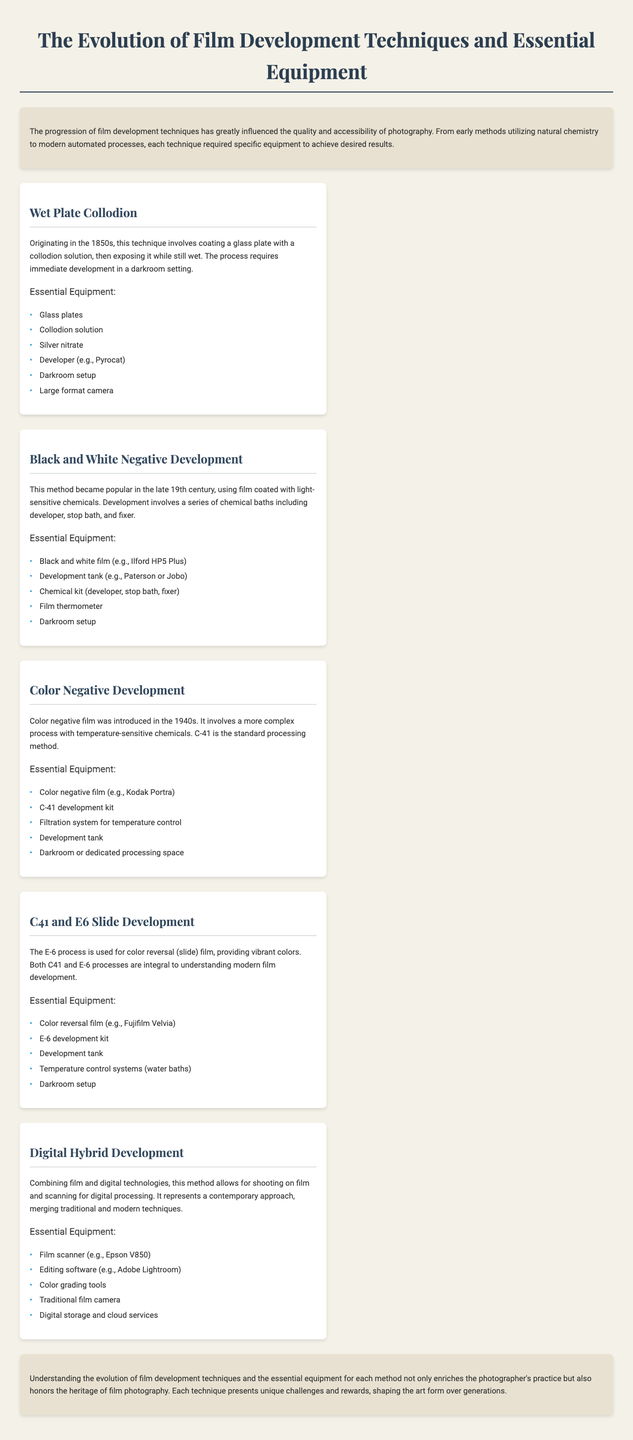What is the first film development technique mentioned? The first technique in the document is Wet Plate Collodion, which was introduced in the 1850s.
Answer: Wet Plate Collodion What year did color negative film become popular? The document states that color negative film was introduced in the 1940s.
Answer: 1940s Which equipment is essential for Black and White Negative Development? The essential equipment list for Black and White Negative Development includes specific items such as the development tank, film thermometer, and others.
Answer: Development tank What is the main purpose of the E-6 process? The E-6 process is primarily used for color reversal (slide) film, noted for producing vibrant colors.
Answer: Color reversal How many key techniques are highlighted in the document? The document outlines five key film development techniques that are detailed.
Answer: Five Which film scanner is recommended in the Digital Hybrid Development section? The document specifies the Epson V850 as the film scanner for Digital Hybrid Development.
Answer: Epson V850 What common feature do C41 and E6 processes share? Both C41 and E-6 processes are integral to understanding modern film development as per the document's comparison.
Answer: Modern film development What do all techniques in the document require? Each development technique mentions the essential need for a darkroom setup among other specific equipment requirements.
Answer: Darkroom setup 